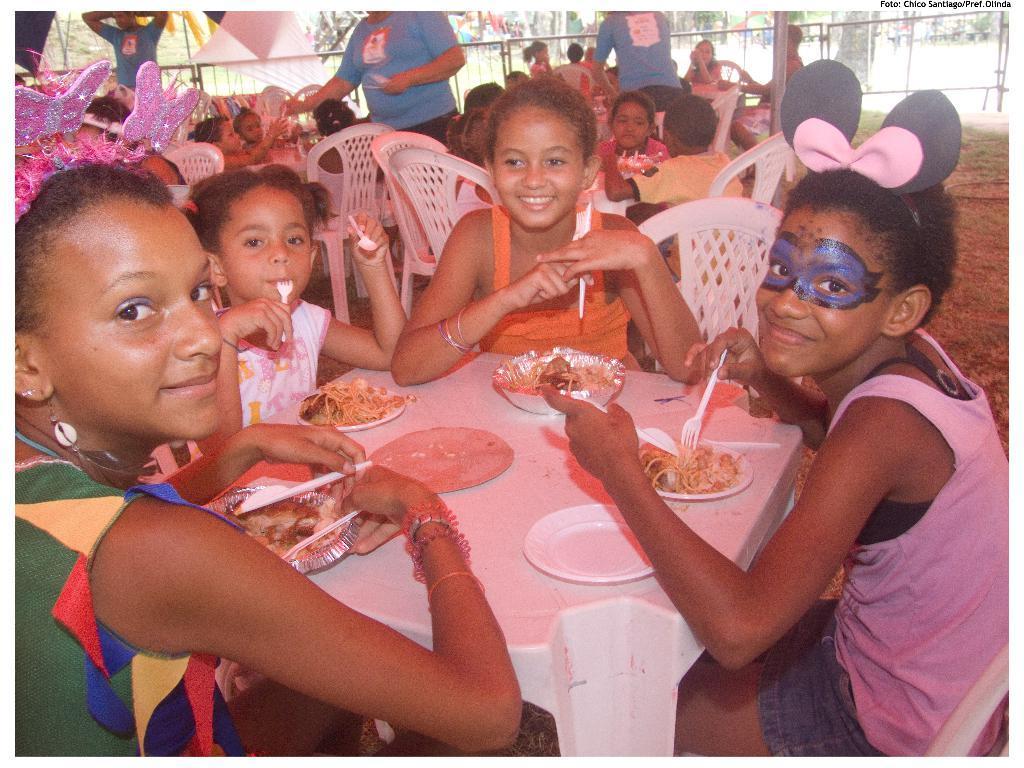In one or two sentences, can you explain what this image depicts? In this image we can see few people sitting on the chairs, some of them are standing and some of them are holding few objects a and there are few plates with food items on the table and there is a railing in the background. 